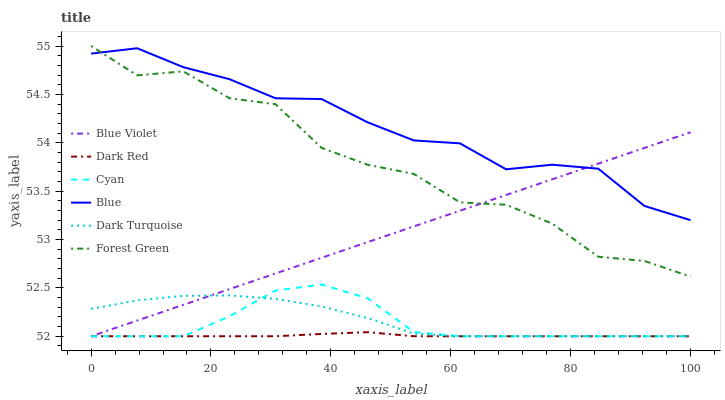Does Dark Red have the minimum area under the curve?
Answer yes or no. Yes. Does Blue have the maximum area under the curve?
Answer yes or no. Yes. Does Forest Green have the minimum area under the curve?
Answer yes or no. No. Does Forest Green have the maximum area under the curve?
Answer yes or no. No. Is Blue Violet the smoothest?
Answer yes or no. Yes. Is Forest Green the roughest?
Answer yes or no. Yes. Is Dark Red the smoothest?
Answer yes or no. No. Is Dark Red the roughest?
Answer yes or no. No. Does Forest Green have the lowest value?
Answer yes or no. No. Does Forest Green have the highest value?
Answer yes or no. Yes. Does Dark Red have the highest value?
Answer yes or no. No. Is Dark Turquoise less than Blue?
Answer yes or no. Yes. Is Blue greater than Dark Red?
Answer yes or no. Yes. Does Blue Violet intersect Dark Red?
Answer yes or no. Yes. Is Blue Violet less than Dark Red?
Answer yes or no. No. Is Blue Violet greater than Dark Red?
Answer yes or no. No. Does Dark Turquoise intersect Blue?
Answer yes or no. No. 